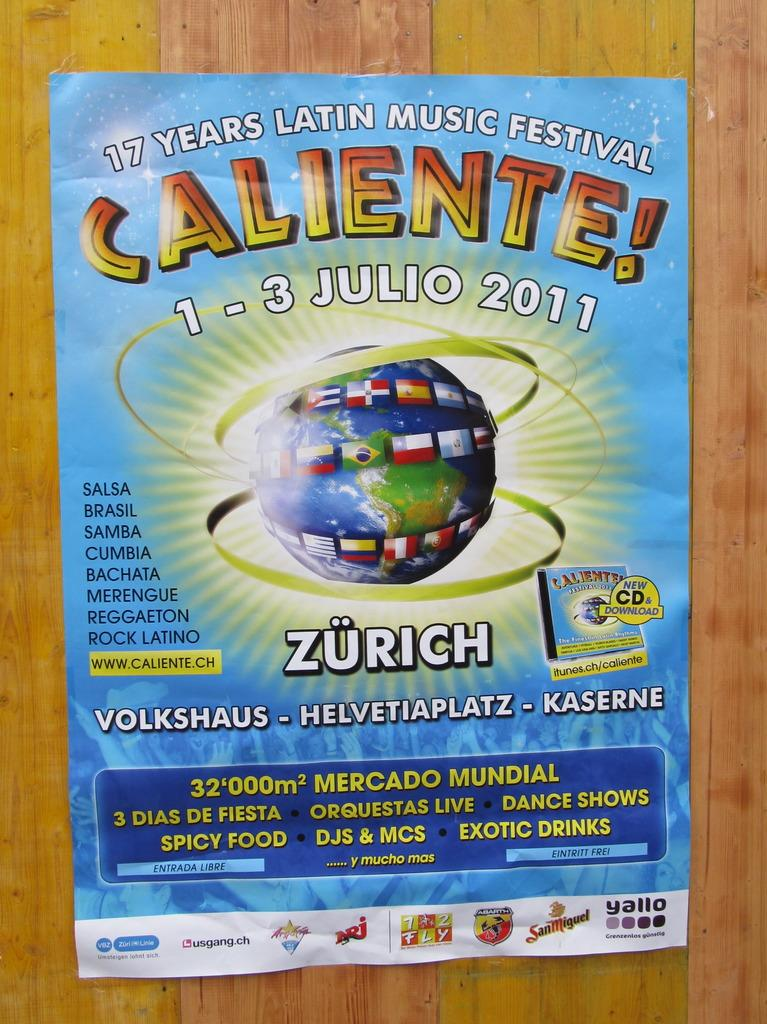<image>
Create a compact narrative representing the image presented. A poster advertising a a Latin Music Festival to take place in Zurich in July. 